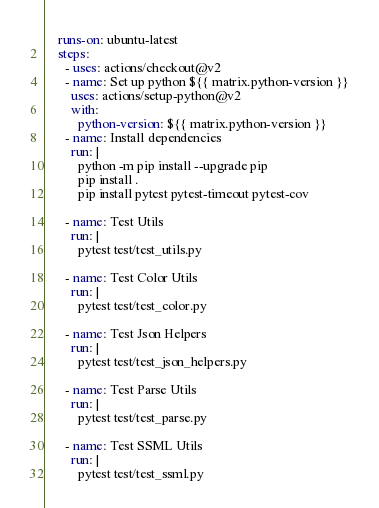<code> <loc_0><loc_0><loc_500><loc_500><_YAML_>    runs-on: ubuntu-latest
    steps:
      - uses: actions/checkout@v2
      - name: Set up python ${{ matrix.python-version }}
        uses: actions/setup-python@v2
        with:
          python-version: ${{ matrix.python-version }}
      - name: Install dependencies
        run: |
          python -m pip install --upgrade pip
          pip install .
          pip install pytest pytest-timeout pytest-cov

      - name: Test Utils
        run: |
          pytest test/test_utils.py

      - name: Test Color Utils
        run: |
          pytest test/test_color.py

      - name: Test Json Helpers
        run: |
          pytest test/test_json_helpers.py

      - name: Test Parse Utils
        run: |
          pytest test/test_parse.py

      - name: Test SSML Utils
        run: |
          pytest test/test_ssml.py</code> 